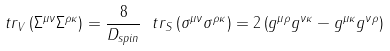<formula> <loc_0><loc_0><loc_500><loc_500>\ t r _ { V } \left ( \Sigma ^ { \mu \nu } \Sigma ^ { \rho \kappa } \right ) = \frac { 8 } { D _ { s p i n } } \ t r _ { S } \left ( \sigma ^ { \mu \nu } \sigma ^ { \rho \kappa } \right ) = 2 \left ( g ^ { \mu \rho } g ^ { \nu \kappa } - g ^ { \mu \kappa } g ^ { \nu \rho } \right )</formula> 